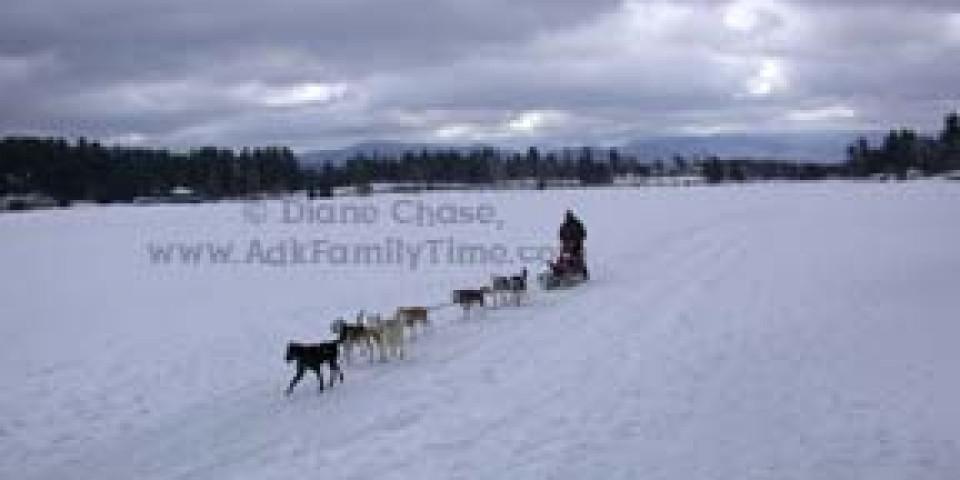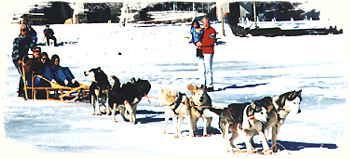The first image is the image on the left, the second image is the image on the right. Analyze the images presented: Is the assertion "There is a person in a red coat in the image on the left" valid? Answer yes or no. No. 